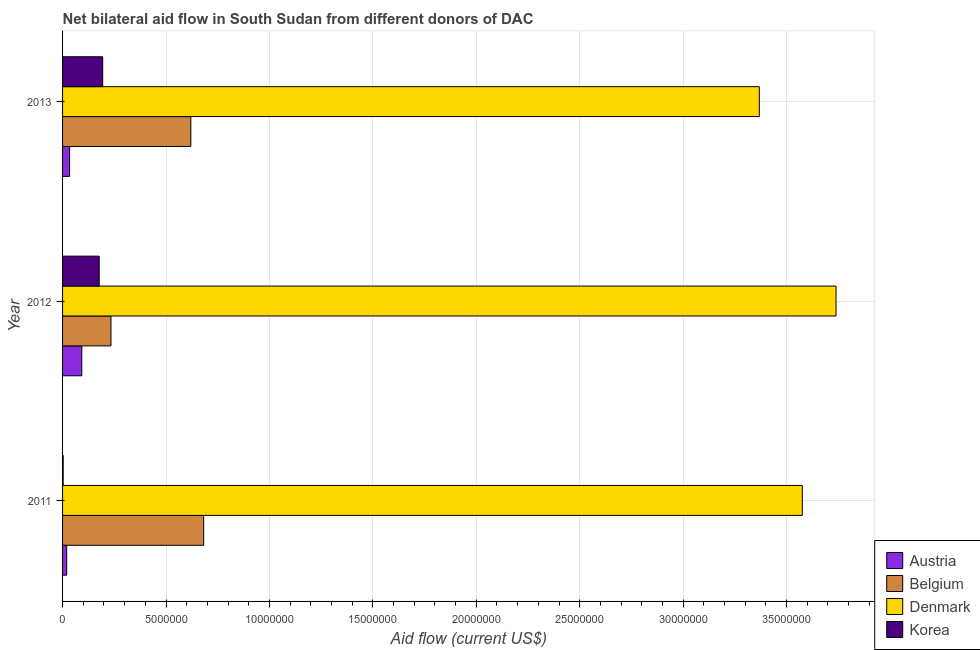How many groups of bars are there?
Give a very brief answer. 3. Are the number of bars per tick equal to the number of legend labels?
Offer a very short reply. Yes. How many bars are there on the 2nd tick from the bottom?
Offer a very short reply. 4. What is the amount of aid given by korea in 2013?
Provide a succinct answer. 1.94e+06. Across all years, what is the maximum amount of aid given by austria?
Ensure brevity in your answer.  9.30e+05. Across all years, what is the minimum amount of aid given by korea?
Your response must be concise. 3.00e+04. What is the total amount of aid given by korea in the graph?
Provide a succinct answer. 3.74e+06. What is the difference between the amount of aid given by belgium in 2011 and that in 2013?
Make the answer very short. 6.20e+05. What is the difference between the amount of aid given by korea in 2012 and the amount of aid given by austria in 2011?
Provide a short and direct response. 1.57e+06. What is the average amount of aid given by belgium per year?
Ensure brevity in your answer.  5.12e+06. In the year 2011, what is the difference between the amount of aid given by belgium and amount of aid given by denmark?
Offer a very short reply. -2.89e+07. What is the ratio of the amount of aid given by belgium in 2012 to that in 2013?
Offer a terse response. 0.38. Is the amount of aid given by denmark in 2012 less than that in 2013?
Offer a very short reply. No. Is the difference between the amount of aid given by belgium in 2011 and 2013 greater than the difference between the amount of aid given by denmark in 2011 and 2013?
Make the answer very short. No. What is the difference between the highest and the second highest amount of aid given by denmark?
Keep it short and to the point. 1.63e+06. What is the difference between the highest and the lowest amount of aid given by austria?
Keep it short and to the point. 7.30e+05. What does the 1st bar from the top in 2012 represents?
Keep it short and to the point. Korea. How many bars are there?
Provide a succinct answer. 12. Where does the legend appear in the graph?
Offer a terse response. Bottom right. How many legend labels are there?
Provide a short and direct response. 4. What is the title of the graph?
Provide a succinct answer. Net bilateral aid flow in South Sudan from different donors of DAC. What is the Aid flow (current US$) in Austria in 2011?
Your answer should be very brief. 2.00e+05. What is the Aid flow (current US$) of Belgium in 2011?
Keep it short and to the point. 6.82e+06. What is the Aid flow (current US$) in Denmark in 2011?
Ensure brevity in your answer.  3.58e+07. What is the Aid flow (current US$) in Korea in 2011?
Your response must be concise. 3.00e+04. What is the Aid flow (current US$) in Austria in 2012?
Make the answer very short. 9.30e+05. What is the Aid flow (current US$) of Belgium in 2012?
Your answer should be very brief. 2.34e+06. What is the Aid flow (current US$) in Denmark in 2012?
Offer a very short reply. 3.74e+07. What is the Aid flow (current US$) of Korea in 2012?
Your answer should be compact. 1.77e+06. What is the Aid flow (current US$) of Austria in 2013?
Offer a terse response. 3.40e+05. What is the Aid flow (current US$) of Belgium in 2013?
Keep it short and to the point. 6.20e+06. What is the Aid flow (current US$) in Denmark in 2013?
Provide a short and direct response. 3.37e+07. What is the Aid flow (current US$) in Korea in 2013?
Your answer should be very brief. 1.94e+06. Across all years, what is the maximum Aid flow (current US$) of Austria?
Provide a succinct answer. 9.30e+05. Across all years, what is the maximum Aid flow (current US$) of Belgium?
Offer a terse response. 6.82e+06. Across all years, what is the maximum Aid flow (current US$) in Denmark?
Provide a short and direct response. 3.74e+07. Across all years, what is the maximum Aid flow (current US$) in Korea?
Provide a succinct answer. 1.94e+06. Across all years, what is the minimum Aid flow (current US$) of Belgium?
Give a very brief answer. 2.34e+06. Across all years, what is the minimum Aid flow (current US$) in Denmark?
Your response must be concise. 3.37e+07. Across all years, what is the minimum Aid flow (current US$) of Korea?
Make the answer very short. 3.00e+04. What is the total Aid flow (current US$) of Austria in the graph?
Provide a succinct answer. 1.47e+06. What is the total Aid flow (current US$) of Belgium in the graph?
Offer a very short reply. 1.54e+07. What is the total Aid flow (current US$) in Denmark in the graph?
Make the answer very short. 1.07e+08. What is the total Aid flow (current US$) in Korea in the graph?
Ensure brevity in your answer.  3.74e+06. What is the difference between the Aid flow (current US$) in Austria in 2011 and that in 2012?
Ensure brevity in your answer.  -7.30e+05. What is the difference between the Aid flow (current US$) of Belgium in 2011 and that in 2012?
Offer a very short reply. 4.48e+06. What is the difference between the Aid flow (current US$) in Denmark in 2011 and that in 2012?
Ensure brevity in your answer.  -1.63e+06. What is the difference between the Aid flow (current US$) in Korea in 2011 and that in 2012?
Offer a terse response. -1.74e+06. What is the difference between the Aid flow (current US$) in Austria in 2011 and that in 2013?
Ensure brevity in your answer.  -1.40e+05. What is the difference between the Aid flow (current US$) in Belgium in 2011 and that in 2013?
Offer a very short reply. 6.20e+05. What is the difference between the Aid flow (current US$) in Denmark in 2011 and that in 2013?
Offer a terse response. 2.08e+06. What is the difference between the Aid flow (current US$) of Korea in 2011 and that in 2013?
Ensure brevity in your answer.  -1.91e+06. What is the difference between the Aid flow (current US$) of Austria in 2012 and that in 2013?
Provide a succinct answer. 5.90e+05. What is the difference between the Aid flow (current US$) of Belgium in 2012 and that in 2013?
Give a very brief answer. -3.86e+06. What is the difference between the Aid flow (current US$) in Denmark in 2012 and that in 2013?
Provide a succinct answer. 3.71e+06. What is the difference between the Aid flow (current US$) in Austria in 2011 and the Aid flow (current US$) in Belgium in 2012?
Give a very brief answer. -2.14e+06. What is the difference between the Aid flow (current US$) in Austria in 2011 and the Aid flow (current US$) in Denmark in 2012?
Make the answer very short. -3.72e+07. What is the difference between the Aid flow (current US$) in Austria in 2011 and the Aid flow (current US$) in Korea in 2012?
Keep it short and to the point. -1.57e+06. What is the difference between the Aid flow (current US$) of Belgium in 2011 and the Aid flow (current US$) of Denmark in 2012?
Ensure brevity in your answer.  -3.06e+07. What is the difference between the Aid flow (current US$) of Belgium in 2011 and the Aid flow (current US$) of Korea in 2012?
Ensure brevity in your answer.  5.05e+06. What is the difference between the Aid flow (current US$) of Denmark in 2011 and the Aid flow (current US$) of Korea in 2012?
Give a very brief answer. 3.40e+07. What is the difference between the Aid flow (current US$) in Austria in 2011 and the Aid flow (current US$) in Belgium in 2013?
Your response must be concise. -6.00e+06. What is the difference between the Aid flow (current US$) of Austria in 2011 and the Aid flow (current US$) of Denmark in 2013?
Your answer should be very brief. -3.35e+07. What is the difference between the Aid flow (current US$) of Austria in 2011 and the Aid flow (current US$) of Korea in 2013?
Offer a very short reply. -1.74e+06. What is the difference between the Aid flow (current US$) in Belgium in 2011 and the Aid flow (current US$) in Denmark in 2013?
Ensure brevity in your answer.  -2.69e+07. What is the difference between the Aid flow (current US$) of Belgium in 2011 and the Aid flow (current US$) of Korea in 2013?
Your answer should be compact. 4.88e+06. What is the difference between the Aid flow (current US$) of Denmark in 2011 and the Aid flow (current US$) of Korea in 2013?
Your answer should be very brief. 3.38e+07. What is the difference between the Aid flow (current US$) in Austria in 2012 and the Aid flow (current US$) in Belgium in 2013?
Provide a short and direct response. -5.27e+06. What is the difference between the Aid flow (current US$) in Austria in 2012 and the Aid flow (current US$) in Denmark in 2013?
Offer a very short reply. -3.28e+07. What is the difference between the Aid flow (current US$) of Austria in 2012 and the Aid flow (current US$) of Korea in 2013?
Give a very brief answer. -1.01e+06. What is the difference between the Aid flow (current US$) in Belgium in 2012 and the Aid flow (current US$) in Denmark in 2013?
Your answer should be compact. -3.13e+07. What is the difference between the Aid flow (current US$) in Belgium in 2012 and the Aid flow (current US$) in Korea in 2013?
Offer a terse response. 4.00e+05. What is the difference between the Aid flow (current US$) of Denmark in 2012 and the Aid flow (current US$) of Korea in 2013?
Your response must be concise. 3.54e+07. What is the average Aid flow (current US$) of Belgium per year?
Keep it short and to the point. 5.12e+06. What is the average Aid flow (current US$) in Denmark per year?
Your response must be concise. 3.56e+07. What is the average Aid flow (current US$) in Korea per year?
Your answer should be very brief. 1.25e+06. In the year 2011, what is the difference between the Aid flow (current US$) of Austria and Aid flow (current US$) of Belgium?
Offer a terse response. -6.62e+06. In the year 2011, what is the difference between the Aid flow (current US$) in Austria and Aid flow (current US$) in Denmark?
Keep it short and to the point. -3.56e+07. In the year 2011, what is the difference between the Aid flow (current US$) of Belgium and Aid flow (current US$) of Denmark?
Offer a very short reply. -2.89e+07. In the year 2011, what is the difference between the Aid flow (current US$) of Belgium and Aid flow (current US$) of Korea?
Offer a very short reply. 6.79e+06. In the year 2011, what is the difference between the Aid flow (current US$) in Denmark and Aid flow (current US$) in Korea?
Provide a succinct answer. 3.57e+07. In the year 2012, what is the difference between the Aid flow (current US$) in Austria and Aid flow (current US$) in Belgium?
Your answer should be very brief. -1.41e+06. In the year 2012, what is the difference between the Aid flow (current US$) in Austria and Aid flow (current US$) in Denmark?
Your response must be concise. -3.65e+07. In the year 2012, what is the difference between the Aid flow (current US$) of Austria and Aid flow (current US$) of Korea?
Ensure brevity in your answer.  -8.40e+05. In the year 2012, what is the difference between the Aid flow (current US$) in Belgium and Aid flow (current US$) in Denmark?
Your answer should be compact. -3.50e+07. In the year 2012, what is the difference between the Aid flow (current US$) of Belgium and Aid flow (current US$) of Korea?
Your answer should be very brief. 5.70e+05. In the year 2012, what is the difference between the Aid flow (current US$) of Denmark and Aid flow (current US$) of Korea?
Provide a short and direct response. 3.56e+07. In the year 2013, what is the difference between the Aid flow (current US$) in Austria and Aid flow (current US$) in Belgium?
Your response must be concise. -5.86e+06. In the year 2013, what is the difference between the Aid flow (current US$) of Austria and Aid flow (current US$) of Denmark?
Give a very brief answer. -3.33e+07. In the year 2013, what is the difference between the Aid flow (current US$) of Austria and Aid flow (current US$) of Korea?
Provide a succinct answer. -1.60e+06. In the year 2013, what is the difference between the Aid flow (current US$) in Belgium and Aid flow (current US$) in Denmark?
Offer a terse response. -2.75e+07. In the year 2013, what is the difference between the Aid flow (current US$) in Belgium and Aid flow (current US$) in Korea?
Offer a terse response. 4.26e+06. In the year 2013, what is the difference between the Aid flow (current US$) of Denmark and Aid flow (current US$) of Korea?
Your answer should be compact. 3.17e+07. What is the ratio of the Aid flow (current US$) of Austria in 2011 to that in 2012?
Make the answer very short. 0.22. What is the ratio of the Aid flow (current US$) in Belgium in 2011 to that in 2012?
Your response must be concise. 2.91. What is the ratio of the Aid flow (current US$) of Denmark in 2011 to that in 2012?
Your response must be concise. 0.96. What is the ratio of the Aid flow (current US$) of Korea in 2011 to that in 2012?
Your answer should be very brief. 0.02. What is the ratio of the Aid flow (current US$) of Austria in 2011 to that in 2013?
Ensure brevity in your answer.  0.59. What is the ratio of the Aid flow (current US$) in Belgium in 2011 to that in 2013?
Provide a succinct answer. 1.1. What is the ratio of the Aid flow (current US$) of Denmark in 2011 to that in 2013?
Offer a terse response. 1.06. What is the ratio of the Aid flow (current US$) of Korea in 2011 to that in 2013?
Ensure brevity in your answer.  0.02. What is the ratio of the Aid flow (current US$) in Austria in 2012 to that in 2013?
Keep it short and to the point. 2.74. What is the ratio of the Aid flow (current US$) in Belgium in 2012 to that in 2013?
Your answer should be compact. 0.38. What is the ratio of the Aid flow (current US$) of Denmark in 2012 to that in 2013?
Offer a terse response. 1.11. What is the ratio of the Aid flow (current US$) in Korea in 2012 to that in 2013?
Your answer should be very brief. 0.91. What is the difference between the highest and the second highest Aid flow (current US$) in Austria?
Give a very brief answer. 5.90e+05. What is the difference between the highest and the second highest Aid flow (current US$) of Belgium?
Provide a succinct answer. 6.20e+05. What is the difference between the highest and the second highest Aid flow (current US$) in Denmark?
Your answer should be very brief. 1.63e+06. What is the difference between the highest and the second highest Aid flow (current US$) of Korea?
Offer a very short reply. 1.70e+05. What is the difference between the highest and the lowest Aid flow (current US$) in Austria?
Provide a succinct answer. 7.30e+05. What is the difference between the highest and the lowest Aid flow (current US$) of Belgium?
Give a very brief answer. 4.48e+06. What is the difference between the highest and the lowest Aid flow (current US$) in Denmark?
Ensure brevity in your answer.  3.71e+06. What is the difference between the highest and the lowest Aid flow (current US$) in Korea?
Keep it short and to the point. 1.91e+06. 